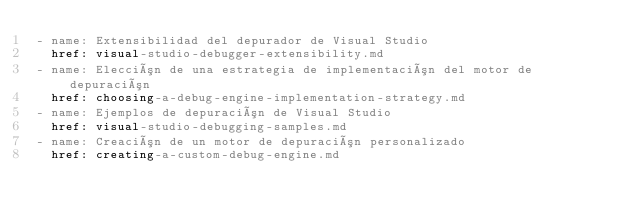<code> <loc_0><loc_0><loc_500><loc_500><_YAML_>- name: Extensibilidad del depurador de Visual Studio
  href: visual-studio-debugger-extensibility.md
- name: Elección de una estrategia de implementación del motor de depuración
  href: choosing-a-debug-engine-implementation-strategy.md
- name: Ejemplos de depuración de Visual Studio
  href: visual-studio-debugging-samples.md
- name: Creación de un motor de depuración personalizado
  href: creating-a-custom-debug-engine.md</code> 